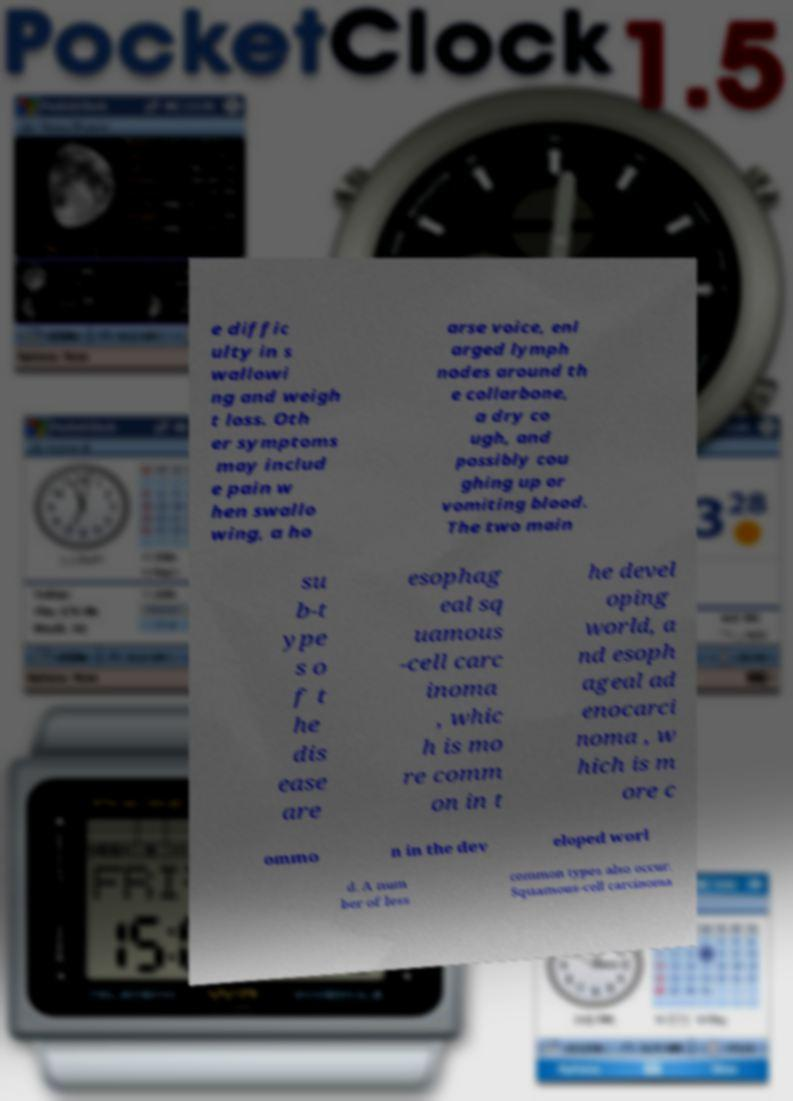For documentation purposes, I need the text within this image transcribed. Could you provide that? e diffic ulty in s wallowi ng and weigh t loss. Oth er symptoms may includ e pain w hen swallo wing, a ho arse voice, enl arged lymph nodes around th e collarbone, a dry co ugh, and possibly cou ghing up or vomiting blood. The two main su b-t ype s o f t he dis ease are esophag eal sq uamous -cell carc inoma , whic h is mo re comm on in t he devel oping world, a nd esoph ageal ad enocarci noma , w hich is m ore c ommo n in the dev eloped worl d. A num ber of less common types also occur. Squamous-cell carcinoma 